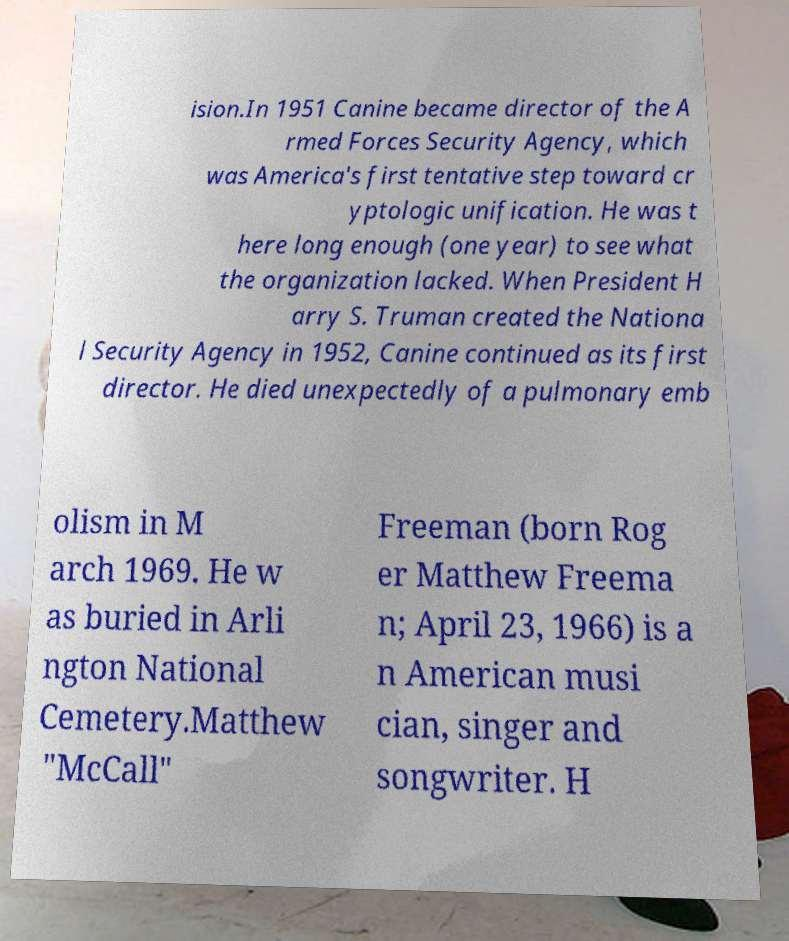Please identify and transcribe the text found in this image. ision.In 1951 Canine became director of the A rmed Forces Security Agency, which was America's first tentative step toward cr yptologic unification. He was t here long enough (one year) to see what the organization lacked. When President H arry S. Truman created the Nationa l Security Agency in 1952, Canine continued as its first director. He died unexpectedly of a pulmonary emb olism in M arch 1969. He w as buried in Arli ngton National Cemetery.Matthew "McCall" Freeman (born Rog er Matthew Freema n; April 23, 1966) is a n American musi cian, singer and songwriter. H 